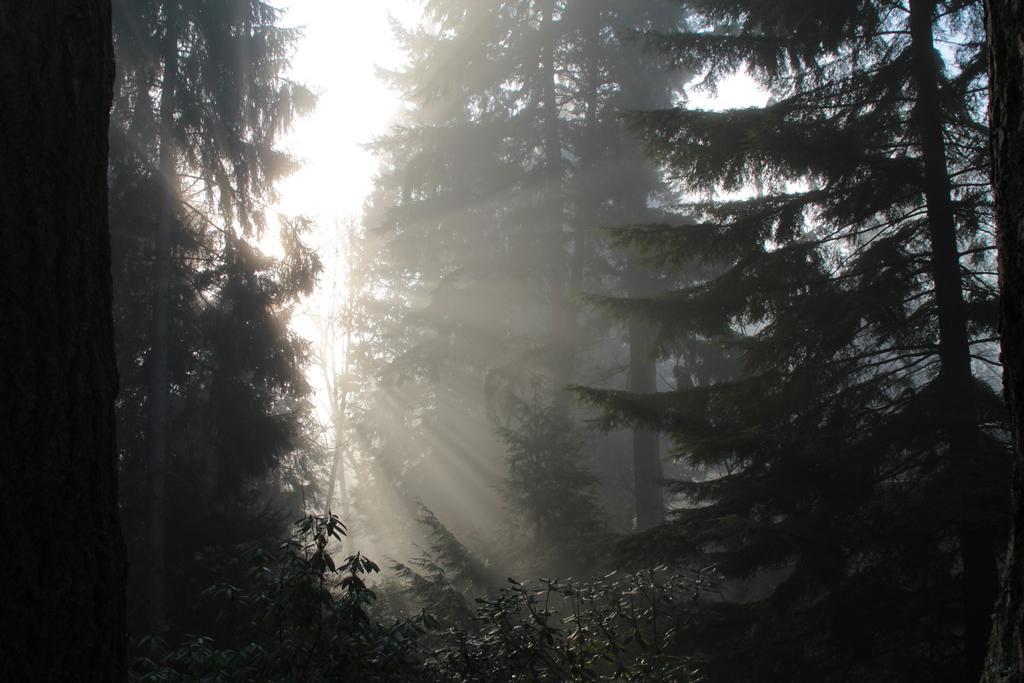Can you describe this image briefly? In this image we can see there are some trees and in the background, we can see the sky. 